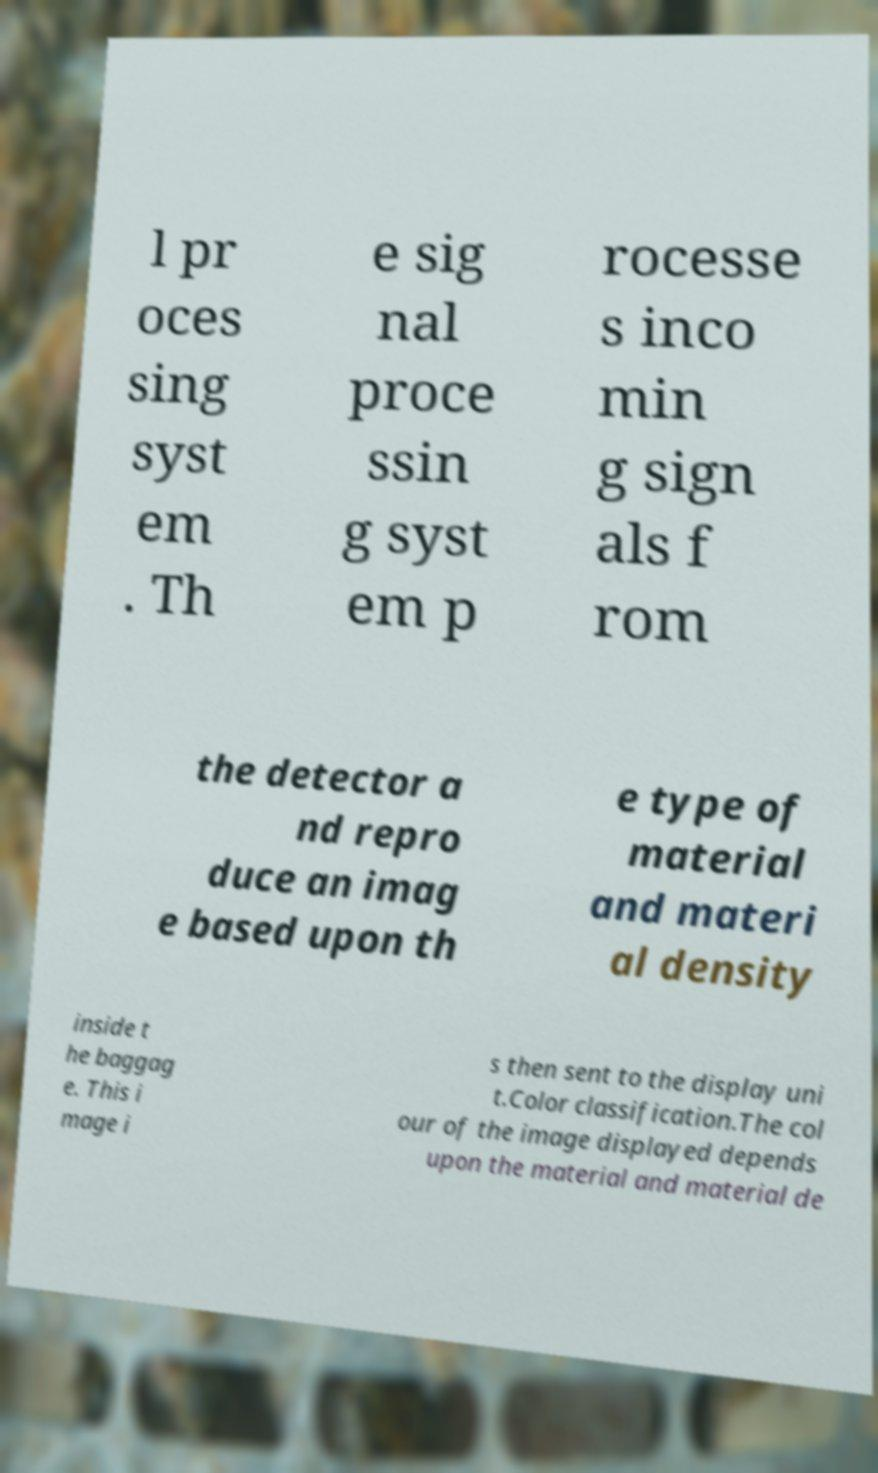Can you read and provide the text displayed in the image?This photo seems to have some interesting text. Can you extract and type it out for me? l pr oces sing syst em . Th e sig nal proce ssin g syst em p rocesse s inco min g sign als f rom the detector a nd repro duce an imag e based upon th e type of material and materi al density inside t he baggag e. This i mage i s then sent to the display uni t.Color classification.The col our of the image displayed depends upon the material and material de 